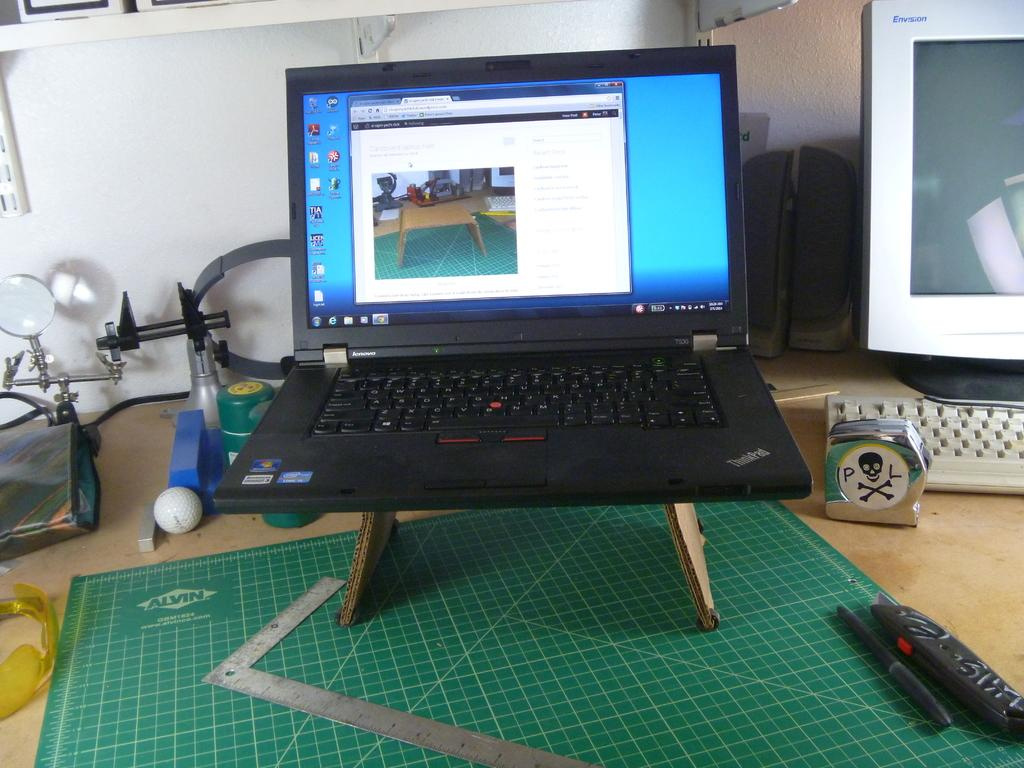<image>
Describe the image concisely. A lenovo laptop is on a stand on a desk. 